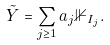Convert formula to latex. <formula><loc_0><loc_0><loc_500><loc_500>\tilde { Y } = \sum _ { j \geq 1 } a _ { j } \mathbb { 1 } _ { I _ { j } } .</formula> 